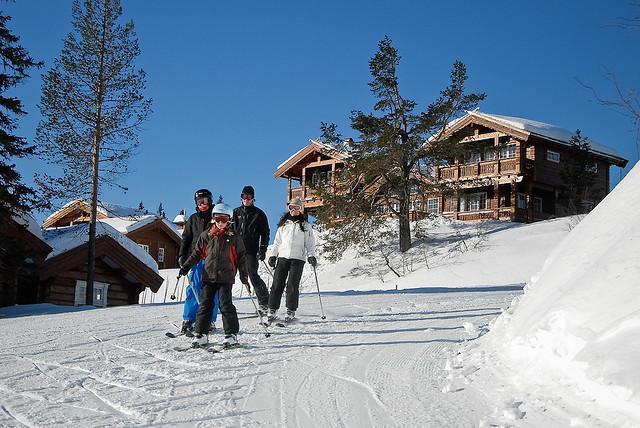How many people can you see?
Give a very brief answer. 4. 